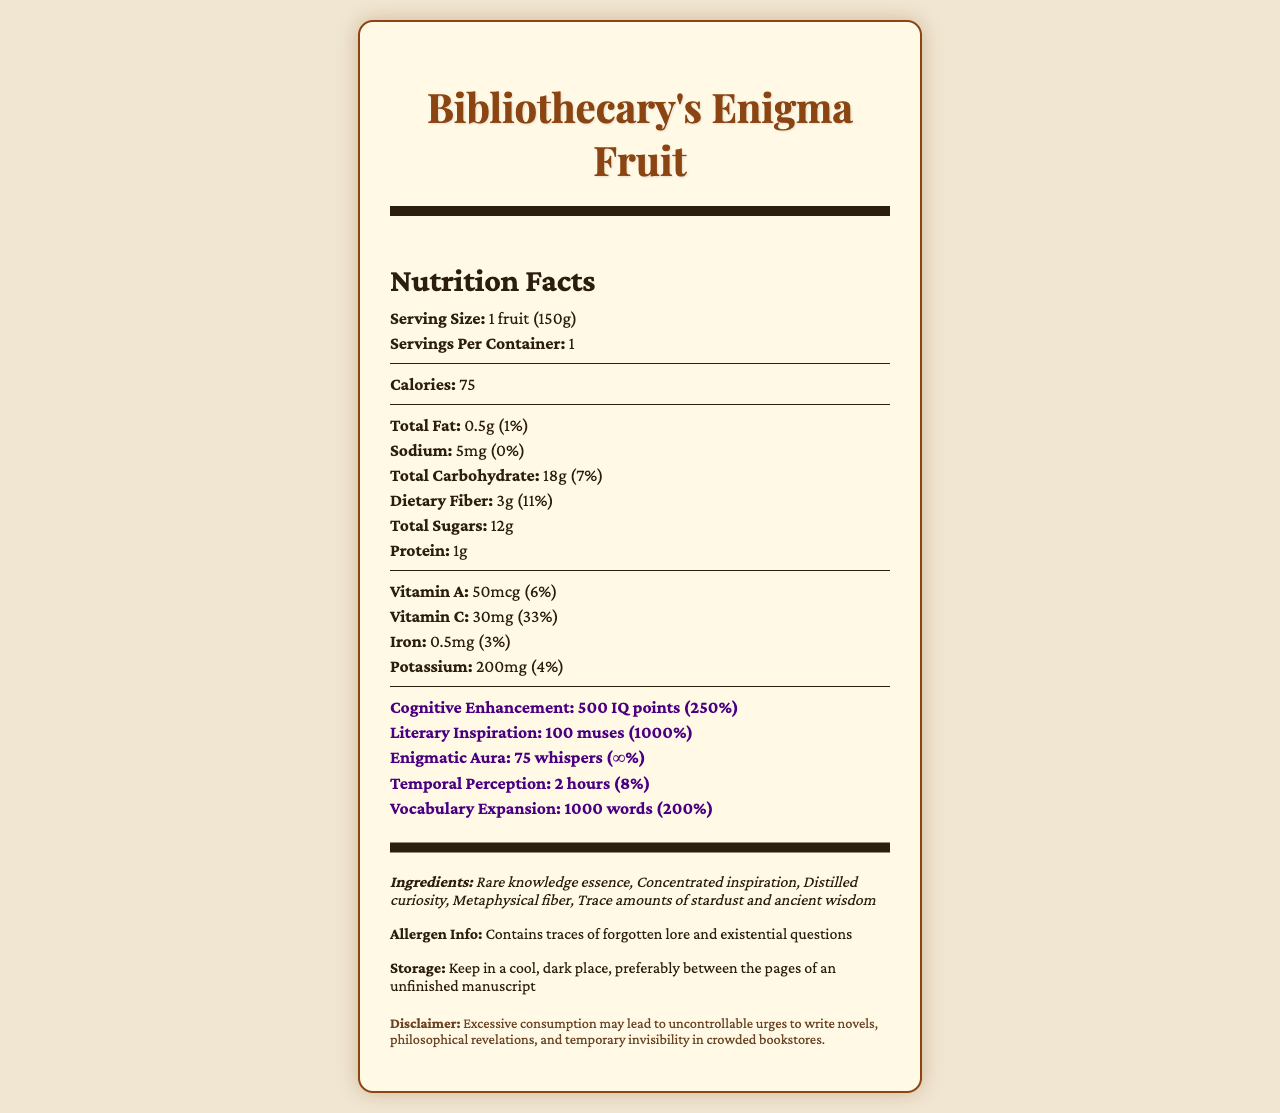who might find the Bibliothecary's Enigma Fruit appealing? The fruit claims to provide significant benefits such as cognitive enhancement, literary inspiration, and vocabulary expansion, making it especially appealing to individuals engaged in intellectual and literary pursuits.
Answer: Aspiring writers and scholars how many calories are there per serving of Bibliothecary's Enigma Fruit? The document states that one serving size (which is one fruit) contains 75 calories.
Answer: 75 calories what is the serving size of the fruit? The document specifies that the serving size is 1 fruit, which weighs 150 grams.
Answer: 1 fruit (150g) how much dietary fiber does it contain? According to the document, the Bibliothecary's Enigma Fruit contains 3 grams of dietary fiber.
Answer: 3g what are the main ingredients in the fruit? The ingredients list includes these unique and magical components.
Answer: Rare knowledge essence, Concentrated inspiration, Distilled curiosity, Metaphysical fiber, Trace amounts of stardust and ancient wisdom what is the daily value percentage of cognitive enhancement provided by the fruit? The document states that the fruit provides 500 IQ points, which is 250% of the daily value of cognitive enhancement.
Answer: 250% what is the vitamin C content in the fruit? The document states that the fruit contains 30mg of vitamin C.
Answer: 30mg for how long does the fruit enhance temporal perception? The document mentions that the fruit provides a temporal perception enhancement for 2 hours.
Answer: 2 hours which one of the following is NOT an ingredient in the Bibliothecary's Enigma Fruit? 
A. Rare knowledge essence 
B. Metaphysical fiber 
C. Ethereal imagination 
D. Distilled curiosity The document lists the ingredients as Rare knowledge essence, Concentrated inspiration, Distilled curiosity, Metaphysical fiber, Trace amounts of stardust and ancient wisdom. Ethereal imagination is not included.
Answer: C. Ethereal imagination which mineral is present in the Bibliothecary's Enigma Fruit? 
I. Sodium 
II. Iron 
III. Potassium 
IV. All of the above The fruit contains 5mg of Sodium, 0.5mg of Iron, and 200mg of Potassium.
Answer: IV. All of the above can consuming the fruit cause temporary invisibility in crowded bookstores? The document's disclaimer mentions that excessive consumption may lead to temporary invisibility in crowded bookstores.
Answer: Yes summarize the main nutritional and intellectual properties of the Bibliothecary's Enigma Fruit. This summary captures the key points about the fruit's nutritional profile, its magical and intellectual properties, and other unique characteristics visible in the document.
Answer: The Bibliothecary's Enigma Fruit is a 150g serving that delivers 75 calories. It contains low amounts of fat and sodium but provides notable dietary fiber and sugar. It is rich in vitamin C and offers unique intellectual properties like enhancing cognitive functions (500 IQ points), literary inspiration (100 muses), an enigmatic aura (75 whispers), temporal perception (2 hours), and vocabulary expansion (1000 words). The ingredients include rare knowledge essence, concentrated inspiration, and other esoteric components. Excessive consumption might lead to philosophical revelations and temporary invisibility. how many muses are provided by the fruit, and what percentage of the daily value does this represent? The document states that the fruit offers 100 muses, which is 1000% of the daily value for literary inspiration.
Answer: 100 muses, 1000% do we know the specific source of the Bibliothecary's Enigma Fruit? The document does not provide any specific information about the source of the fruit; it only mentions its discovery in the library's secret garden.
Answer: Not enough information 